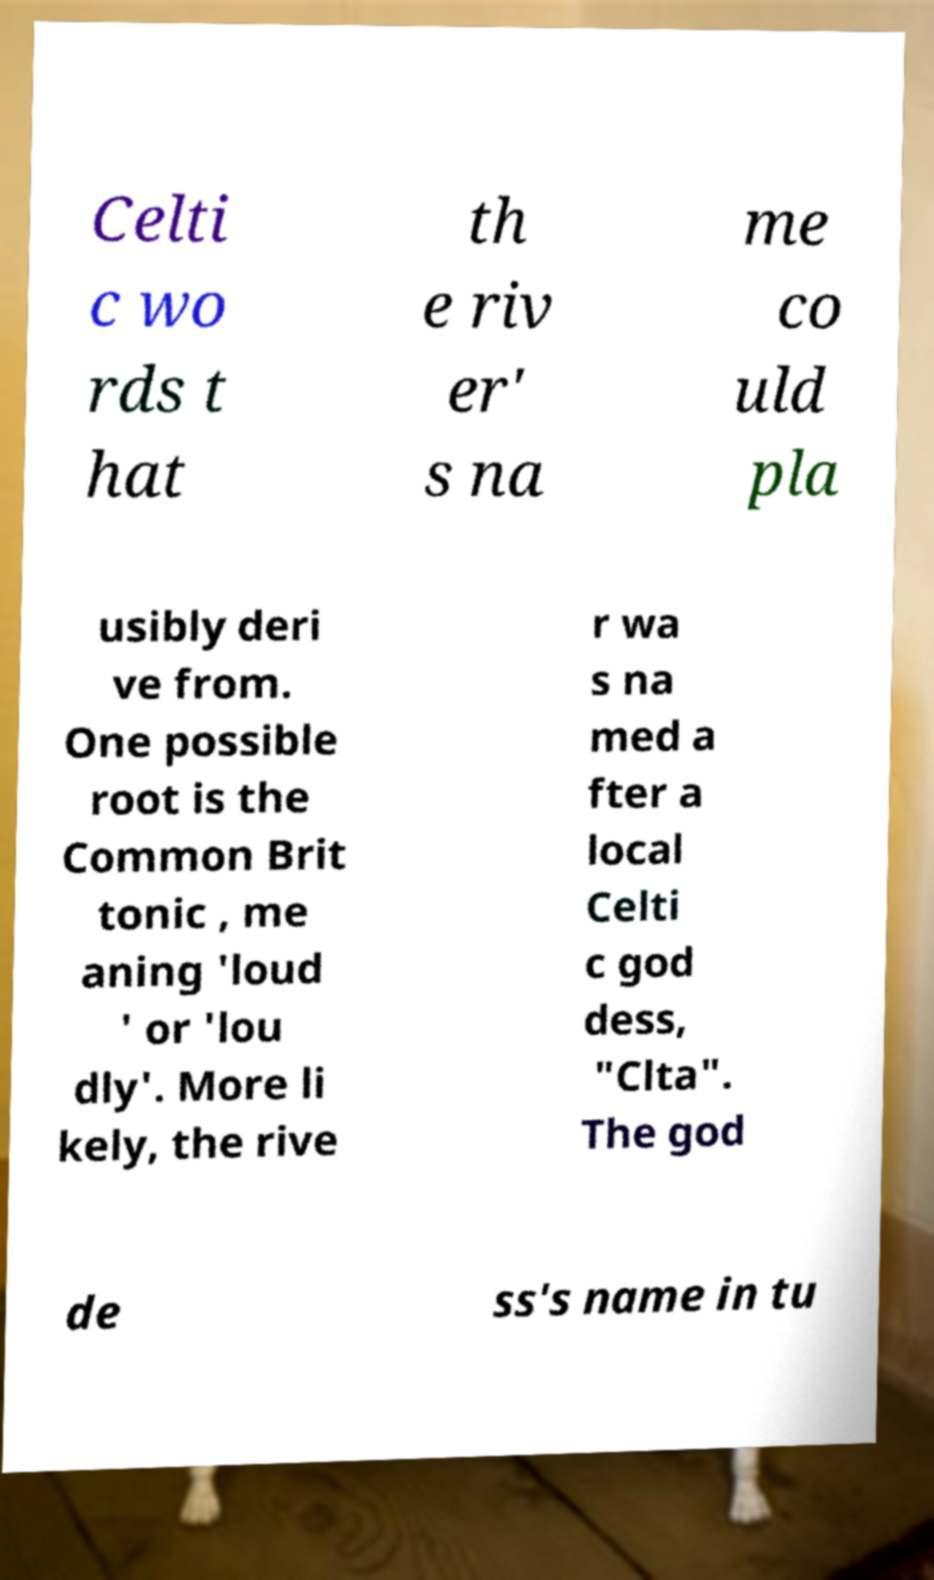There's text embedded in this image that I need extracted. Can you transcribe it verbatim? Celti c wo rds t hat th e riv er' s na me co uld pla usibly deri ve from. One possible root is the Common Brit tonic , me aning 'loud ' or 'lou dly'. More li kely, the rive r wa s na med a fter a local Celti c god dess, "Clta". The god de ss's name in tu 